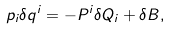Convert formula to latex. <formula><loc_0><loc_0><loc_500><loc_500>p _ { i } \delta q ^ { i } = - P ^ { i } \delta Q _ { i } + \delta B ,</formula> 